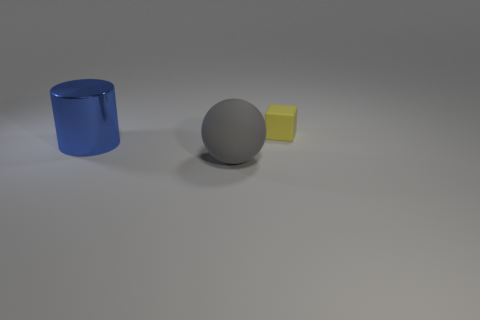Add 2 tiny cubes. How many objects exist? 5 Subtract all cubes. How many objects are left? 2 Add 3 gray things. How many gray things exist? 4 Subtract 0 brown cylinders. How many objects are left? 3 Subtract all small gray matte objects. Subtract all rubber objects. How many objects are left? 1 Add 1 blue metallic things. How many blue metallic things are left? 2 